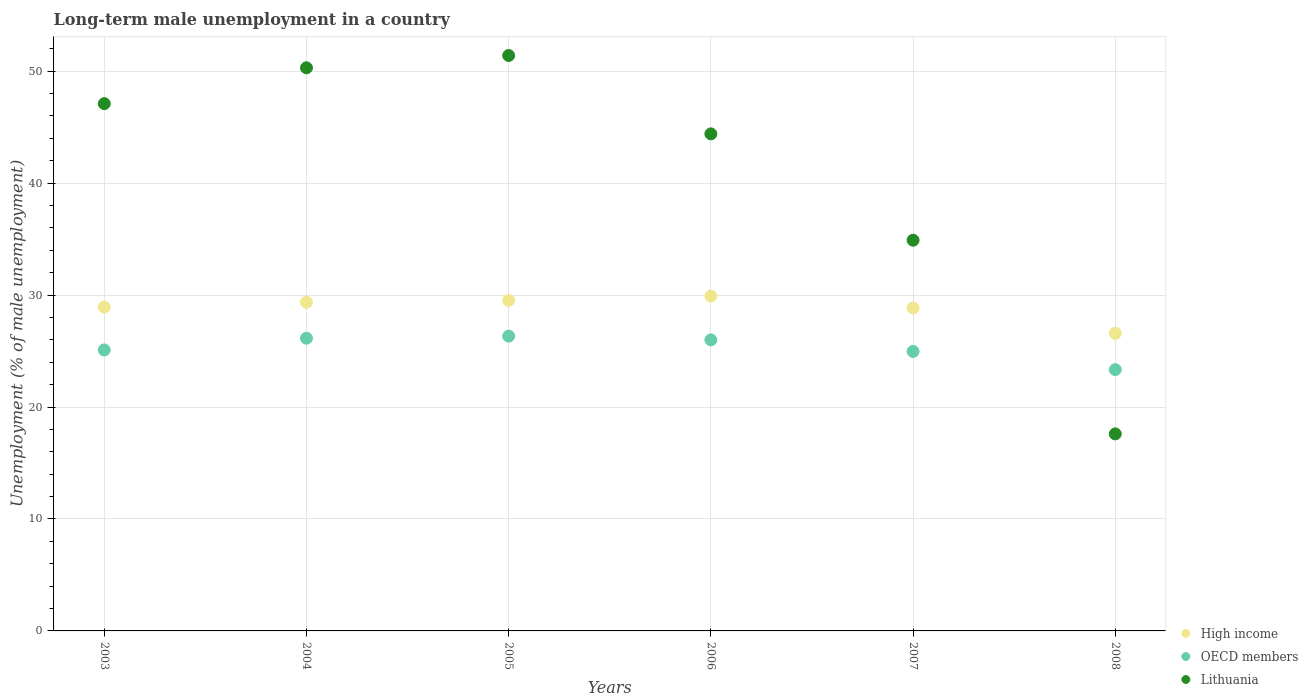How many different coloured dotlines are there?
Provide a short and direct response. 3. What is the percentage of long-term unemployed male population in High income in 2005?
Ensure brevity in your answer.  29.52. Across all years, what is the maximum percentage of long-term unemployed male population in Lithuania?
Offer a very short reply. 51.4. Across all years, what is the minimum percentage of long-term unemployed male population in High income?
Offer a terse response. 26.59. In which year was the percentage of long-term unemployed male population in OECD members maximum?
Your answer should be very brief. 2005. What is the total percentage of long-term unemployed male population in OECD members in the graph?
Your answer should be compact. 151.88. What is the difference between the percentage of long-term unemployed male population in High income in 2003 and that in 2006?
Offer a terse response. -0.98. What is the difference between the percentage of long-term unemployed male population in High income in 2004 and the percentage of long-term unemployed male population in OECD members in 2003?
Give a very brief answer. 4.26. What is the average percentage of long-term unemployed male population in High income per year?
Your response must be concise. 28.86. In the year 2003, what is the difference between the percentage of long-term unemployed male population in OECD members and percentage of long-term unemployed male population in High income?
Offer a terse response. -3.83. What is the ratio of the percentage of long-term unemployed male population in High income in 2003 to that in 2008?
Provide a succinct answer. 1.09. Is the percentage of long-term unemployed male population in OECD members in 2007 less than that in 2008?
Your response must be concise. No. Is the difference between the percentage of long-term unemployed male population in OECD members in 2003 and 2006 greater than the difference between the percentage of long-term unemployed male population in High income in 2003 and 2006?
Offer a terse response. Yes. What is the difference between the highest and the second highest percentage of long-term unemployed male population in High income?
Offer a very short reply. 0.38. What is the difference between the highest and the lowest percentage of long-term unemployed male population in High income?
Offer a terse response. 3.32. In how many years, is the percentage of long-term unemployed male population in Lithuania greater than the average percentage of long-term unemployed male population in Lithuania taken over all years?
Your answer should be compact. 4. Is the percentage of long-term unemployed male population in OECD members strictly greater than the percentage of long-term unemployed male population in High income over the years?
Your response must be concise. No. Is the percentage of long-term unemployed male population in OECD members strictly less than the percentage of long-term unemployed male population in High income over the years?
Your answer should be compact. Yes. How many dotlines are there?
Provide a succinct answer. 3. Are the values on the major ticks of Y-axis written in scientific E-notation?
Make the answer very short. No. What is the title of the graph?
Provide a short and direct response. Long-term male unemployment in a country. What is the label or title of the X-axis?
Provide a short and direct response. Years. What is the label or title of the Y-axis?
Provide a short and direct response. Unemployment (% of male unemployment). What is the Unemployment (% of male unemployment) of High income in 2003?
Offer a terse response. 28.93. What is the Unemployment (% of male unemployment) of OECD members in 2003?
Your answer should be compact. 25.1. What is the Unemployment (% of male unemployment) in Lithuania in 2003?
Your answer should be very brief. 47.1. What is the Unemployment (% of male unemployment) of High income in 2004?
Offer a very short reply. 29.36. What is the Unemployment (% of male unemployment) of OECD members in 2004?
Make the answer very short. 26.15. What is the Unemployment (% of male unemployment) in Lithuania in 2004?
Your answer should be very brief. 50.3. What is the Unemployment (% of male unemployment) in High income in 2005?
Offer a terse response. 29.52. What is the Unemployment (% of male unemployment) of OECD members in 2005?
Give a very brief answer. 26.33. What is the Unemployment (% of male unemployment) of Lithuania in 2005?
Your answer should be compact. 51.4. What is the Unemployment (% of male unemployment) in High income in 2006?
Your answer should be very brief. 29.91. What is the Unemployment (% of male unemployment) in OECD members in 2006?
Your answer should be very brief. 26. What is the Unemployment (% of male unemployment) in Lithuania in 2006?
Your response must be concise. 44.4. What is the Unemployment (% of male unemployment) in High income in 2007?
Your answer should be compact. 28.85. What is the Unemployment (% of male unemployment) of OECD members in 2007?
Keep it short and to the point. 24.96. What is the Unemployment (% of male unemployment) of Lithuania in 2007?
Keep it short and to the point. 34.9. What is the Unemployment (% of male unemployment) of High income in 2008?
Make the answer very short. 26.59. What is the Unemployment (% of male unemployment) of OECD members in 2008?
Your answer should be very brief. 23.34. What is the Unemployment (% of male unemployment) in Lithuania in 2008?
Provide a short and direct response. 17.6. Across all years, what is the maximum Unemployment (% of male unemployment) in High income?
Provide a short and direct response. 29.91. Across all years, what is the maximum Unemployment (% of male unemployment) of OECD members?
Your response must be concise. 26.33. Across all years, what is the maximum Unemployment (% of male unemployment) of Lithuania?
Provide a succinct answer. 51.4. Across all years, what is the minimum Unemployment (% of male unemployment) in High income?
Offer a terse response. 26.59. Across all years, what is the minimum Unemployment (% of male unemployment) of OECD members?
Keep it short and to the point. 23.34. Across all years, what is the minimum Unemployment (% of male unemployment) of Lithuania?
Keep it short and to the point. 17.6. What is the total Unemployment (% of male unemployment) of High income in the graph?
Your response must be concise. 173.15. What is the total Unemployment (% of male unemployment) in OECD members in the graph?
Your answer should be compact. 151.88. What is the total Unemployment (% of male unemployment) of Lithuania in the graph?
Your answer should be very brief. 245.7. What is the difference between the Unemployment (% of male unemployment) of High income in 2003 and that in 2004?
Ensure brevity in your answer.  -0.43. What is the difference between the Unemployment (% of male unemployment) of OECD members in 2003 and that in 2004?
Provide a succinct answer. -1.05. What is the difference between the Unemployment (% of male unemployment) in Lithuania in 2003 and that in 2004?
Ensure brevity in your answer.  -3.2. What is the difference between the Unemployment (% of male unemployment) in High income in 2003 and that in 2005?
Provide a short and direct response. -0.6. What is the difference between the Unemployment (% of male unemployment) of OECD members in 2003 and that in 2005?
Ensure brevity in your answer.  -1.23. What is the difference between the Unemployment (% of male unemployment) in Lithuania in 2003 and that in 2005?
Your answer should be very brief. -4.3. What is the difference between the Unemployment (% of male unemployment) in High income in 2003 and that in 2006?
Provide a short and direct response. -0.98. What is the difference between the Unemployment (% of male unemployment) in OECD members in 2003 and that in 2006?
Give a very brief answer. -0.9. What is the difference between the Unemployment (% of male unemployment) in High income in 2003 and that in 2007?
Ensure brevity in your answer.  0.08. What is the difference between the Unemployment (% of male unemployment) of OECD members in 2003 and that in 2007?
Your answer should be very brief. 0.13. What is the difference between the Unemployment (% of male unemployment) of Lithuania in 2003 and that in 2007?
Offer a very short reply. 12.2. What is the difference between the Unemployment (% of male unemployment) in High income in 2003 and that in 2008?
Provide a short and direct response. 2.34. What is the difference between the Unemployment (% of male unemployment) in OECD members in 2003 and that in 2008?
Offer a very short reply. 1.76. What is the difference between the Unemployment (% of male unemployment) of Lithuania in 2003 and that in 2008?
Your response must be concise. 29.5. What is the difference between the Unemployment (% of male unemployment) of High income in 2004 and that in 2005?
Your answer should be compact. -0.17. What is the difference between the Unemployment (% of male unemployment) in OECD members in 2004 and that in 2005?
Ensure brevity in your answer.  -0.18. What is the difference between the Unemployment (% of male unemployment) in High income in 2004 and that in 2006?
Make the answer very short. -0.55. What is the difference between the Unemployment (% of male unemployment) in OECD members in 2004 and that in 2006?
Keep it short and to the point. 0.15. What is the difference between the Unemployment (% of male unemployment) of Lithuania in 2004 and that in 2006?
Give a very brief answer. 5.9. What is the difference between the Unemployment (% of male unemployment) in High income in 2004 and that in 2007?
Make the answer very short. 0.51. What is the difference between the Unemployment (% of male unemployment) of OECD members in 2004 and that in 2007?
Your response must be concise. 1.18. What is the difference between the Unemployment (% of male unemployment) in High income in 2004 and that in 2008?
Your response must be concise. 2.77. What is the difference between the Unemployment (% of male unemployment) in OECD members in 2004 and that in 2008?
Provide a short and direct response. 2.81. What is the difference between the Unemployment (% of male unemployment) in Lithuania in 2004 and that in 2008?
Give a very brief answer. 32.7. What is the difference between the Unemployment (% of male unemployment) in High income in 2005 and that in 2006?
Ensure brevity in your answer.  -0.38. What is the difference between the Unemployment (% of male unemployment) in OECD members in 2005 and that in 2006?
Ensure brevity in your answer.  0.33. What is the difference between the Unemployment (% of male unemployment) of Lithuania in 2005 and that in 2006?
Provide a short and direct response. 7. What is the difference between the Unemployment (% of male unemployment) of High income in 2005 and that in 2007?
Your response must be concise. 0.67. What is the difference between the Unemployment (% of male unemployment) of OECD members in 2005 and that in 2007?
Your answer should be very brief. 1.37. What is the difference between the Unemployment (% of male unemployment) in Lithuania in 2005 and that in 2007?
Offer a very short reply. 16.5. What is the difference between the Unemployment (% of male unemployment) in High income in 2005 and that in 2008?
Your response must be concise. 2.93. What is the difference between the Unemployment (% of male unemployment) in OECD members in 2005 and that in 2008?
Offer a terse response. 2.99. What is the difference between the Unemployment (% of male unemployment) in Lithuania in 2005 and that in 2008?
Offer a terse response. 33.8. What is the difference between the Unemployment (% of male unemployment) in High income in 2006 and that in 2007?
Make the answer very short. 1.06. What is the difference between the Unemployment (% of male unemployment) in OECD members in 2006 and that in 2007?
Give a very brief answer. 1.04. What is the difference between the Unemployment (% of male unemployment) of High income in 2006 and that in 2008?
Your answer should be compact. 3.32. What is the difference between the Unemployment (% of male unemployment) in OECD members in 2006 and that in 2008?
Offer a very short reply. 2.66. What is the difference between the Unemployment (% of male unemployment) of Lithuania in 2006 and that in 2008?
Offer a terse response. 26.8. What is the difference between the Unemployment (% of male unemployment) in High income in 2007 and that in 2008?
Make the answer very short. 2.26. What is the difference between the Unemployment (% of male unemployment) in OECD members in 2007 and that in 2008?
Offer a very short reply. 1.62. What is the difference between the Unemployment (% of male unemployment) of Lithuania in 2007 and that in 2008?
Ensure brevity in your answer.  17.3. What is the difference between the Unemployment (% of male unemployment) of High income in 2003 and the Unemployment (% of male unemployment) of OECD members in 2004?
Your answer should be compact. 2.78. What is the difference between the Unemployment (% of male unemployment) in High income in 2003 and the Unemployment (% of male unemployment) in Lithuania in 2004?
Your answer should be compact. -21.37. What is the difference between the Unemployment (% of male unemployment) of OECD members in 2003 and the Unemployment (% of male unemployment) of Lithuania in 2004?
Give a very brief answer. -25.2. What is the difference between the Unemployment (% of male unemployment) of High income in 2003 and the Unemployment (% of male unemployment) of OECD members in 2005?
Give a very brief answer. 2.6. What is the difference between the Unemployment (% of male unemployment) of High income in 2003 and the Unemployment (% of male unemployment) of Lithuania in 2005?
Provide a succinct answer. -22.47. What is the difference between the Unemployment (% of male unemployment) of OECD members in 2003 and the Unemployment (% of male unemployment) of Lithuania in 2005?
Offer a very short reply. -26.3. What is the difference between the Unemployment (% of male unemployment) of High income in 2003 and the Unemployment (% of male unemployment) of OECD members in 2006?
Offer a very short reply. 2.93. What is the difference between the Unemployment (% of male unemployment) in High income in 2003 and the Unemployment (% of male unemployment) in Lithuania in 2006?
Your response must be concise. -15.47. What is the difference between the Unemployment (% of male unemployment) of OECD members in 2003 and the Unemployment (% of male unemployment) of Lithuania in 2006?
Provide a succinct answer. -19.3. What is the difference between the Unemployment (% of male unemployment) of High income in 2003 and the Unemployment (% of male unemployment) of OECD members in 2007?
Offer a terse response. 3.96. What is the difference between the Unemployment (% of male unemployment) of High income in 2003 and the Unemployment (% of male unemployment) of Lithuania in 2007?
Give a very brief answer. -5.97. What is the difference between the Unemployment (% of male unemployment) of OECD members in 2003 and the Unemployment (% of male unemployment) of Lithuania in 2007?
Give a very brief answer. -9.8. What is the difference between the Unemployment (% of male unemployment) in High income in 2003 and the Unemployment (% of male unemployment) in OECD members in 2008?
Keep it short and to the point. 5.59. What is the difference between the Unemployment (% of male unemployment) of High income in 2003 and the Unemployment (% of male unemployment) of Lithuania in 2008?
Your answer should be very brief. 11.33. What is the difference between the Unemployment (% of male unemployment) of OECD members in 2003 and the Unemployment (% of male unemployment) of Lithuania in 2008?
Ensure brevity in your answer.  7.5. What is the difference between the Unemployment (% of male unemployment) of High income in 2004 and the Unemployment (% of male unemployment) of OECD members in 2005?
Ensure brevity in your answer.  3.02. What is the difference between the Unemployment (% of male unemployment) in High income in 2004 and the Unemployment (% of male unemployment) in Lithuania in 2005?
Provide a short and direct response. -22.04. What is the difference between the Unemployment (% of male unemployment) in OECD members in 2004 and the Unemployment (% of male unemployment) in Lithuania in 2005?
Your answer should be very brief. -25.25. What is the difference between the Unemployment (% of male unemployment) in High income in 2004 and the Unemployment (% of male unemployment) in OECD members in 2006?
Give a very brief answer. 3.36. What is the difference between the Unemployment (% of male unemployment) in High income in 2004 and the Unemployment (% of male unemployment) in Lithuania in 2006?
Keep it short and to the point. -15.04. What is the difference between the Unemployment (% of male unemployment) in OECD members in 2004 and the Unemployment (% of male unemployment) in Lithuania in 2006?
Ensure brevity in your answer.  -18.25. What is the difference between the Unemployment (% of male unemployment) of High income in 2004 and the Unemployment (% of male unemployment) of OECD members in 2007?
Your response must be concise. 4.39. What is the difference between the Unemployment (% of male unemployment) in High income in 2004 and the Unemployment (% of male unemployment) in Lithuania in 2007?
Ensure brevity in your answer.  -5.54. What is the difference between the Unemployment (% of male unemployment) of OECD members in 2004 and the Unemployment (% of male unemployment) of Lithuania in 2007?
Your response must be concise. -8.75. What is the difference between the Unemployment (% of male unemployment) in High income in 2004 and the Unemployment (% of male unemployment) in OECD members in 2008?
Keep it short and to the point. 6.01. What is the difference between the Unemployment (% of male unemployment) of High income in 2004 and the Unemployment (% of male unemployment) of Lithuania in 2008?
Provide a short and direct response. 11.76. What is the difference between the Unemployment (% of male unemployment) in OECD members in 2004 and the Unemployment (% of male unemployment) in Lithuania in 2008?
Ensure brevity in your answer.  8.55. What is the difference between the Unemployment (% of male unemployment) in High income in 2005 and the Unemployment (% of male unemployment) in OECD members in 2006?
Make the answer very short. 3.52. What is the difference between the Unemployment (% of male unemployment) in High income in 2005 and the Unemployment (% of male unemployment) in Lithuania in 2006?
Offer a very short reply. -14.88. What is the difference between the Unemployment (% of male unemployment) of OECD members in 2005 and the Unemployment (% of male unemployment) of Lithuania in 2006?
Your answer should be compact. -18.07. What is the difference between the Unemployment (% of male unemployment) in High income in 2005 and the Unemployment (% of male unemployment) in OECD members in 2007?
Provide a short and direct response. 4.56. What is the difference between the Unemployment (% of male unemployment) in High income in 2005 and the Unemployment (% of male unemployment) in Lithuania in 2007?
Offer a terse response. -5.38. What is the difference between the Unemployment (% of male unemployment) in OECD members in 2005 and the Unemployment (% of male unemployment) in Lithuania in 2007?
Provide a short and direct response. -8.57. What is the difference between the Unemployment (% of male unemployment) in High income in 2005 and the Unemployment (% of male unemployment) in OECD members in 2008?
Make the answer very short. 6.18. What is the difference between the Unemployment (% of male unemployment) in High income in 2005 and the Unemployment (% of male unemployment) in Lithuania in 2008?
Give a very brief answer. 11.92. What is the difference between the Unemployment (% of male unemployment) of OECD members in 2005 and the Unemployment (% of male unemployment) of Lithuania in 2008?
Your answer should be compact. 8.73. What is the difference between the Unemployment (% of male unemployment) in High income in 2006 and the Unemployment (% of male unemployment) in OECD members in 2007?
Keep it short and to the point. 4.94. What is the difference between the Unemployment (% of male unemployment) of High income in 2006 and the Unemployment (% of male unemployment) of Lithuania in 2007?
Provide a short and direct response. -4.99. What is the difference between the Unemployment (% of male unemployment) of OECD members in 2006 and the Unemployment (% of male unemployment) of Lithuania in 2007?
Provide a short and direct response. -8.9. What is the difference between the Unemployment (% of male unemployment) of High income in 2006 and the Unemployment (% of male unemployment) of OECD members in 2008?
Offer a terse response. 6.56. What is the difference between the Unemployment (% of male unemployment) in High income in 2006 and the Unemployment (% of male unemployment) in Lithuania in 2008?
Offer a terse response. 12.31. What is the difference between the Unemployment (% of male unemployment) of OECD members in 2006 and the Unemployment (% of male unemployment) of Lithuania in 2008?
Your answer should be compact. 8.4. What is the difference between the Unemployment (% of male unemployment) of High income in 2007 and the Unemployment (% of male unemployment) of OECD members in 2008?
Give a very brief answer. 5.51. What is the difference between the Unemployment (% of male unemployment) in High income in 2007 and the Unemployment (% of male unemployment) in Lithuania in 2008?
Keep it short and to the point. 11.25. What is the difference between the Unemployment (% of male unemployment) of OECD members in 2007 and the Unemployment (% of male unemployment) of Lithuania in 2008?
Make the answer very short. 7.36. What is the average Unemployment (% of male unemployment) in High income per year?
Your answer should be very brief. 28.86. What is the average Unemployment (% of male unemployment) in OECD members per year?
Your answer should be compact. 25.31. What is the average Unemployment (% of male unemployment) in Lithuania per year?
Your response must be concise. 40.95. In the year 2003, what is the difference between the Unemployment (% of male unemployment) of High income and Unemployment (% of male unemployment) of OECD members?
Your response must be concise. 3.83. In the year 2003, what is the difference between the Unemployment (% of male unemployment) of High income and Unemployment (% of male unemployment) of Lithuania?
Offer a terse response. -18.17. In the year 2003, what is the difference between the Unemployment (% of male unemployment) of OECD members and Unemployment (% of male unemployment) of Lithuania?
Make the answer very short. -22. In the year 2004, what is the difference between the Unemployment (% of male unemployment) in High income and Unemployment (% of male unemployment) in OECD members?
Ensure brevity in your answer.  3.21. In the year 2004, what is the difference between the Unemployment (% of male unemployment) of High income and Unemployment (% of male unemployment) of Lithuania?
Your answer should be very brief. -20.94. In the year 2004, what is the difference between the Unemployment (% of male unemployment) of OECD members and Unemployment (% of male unemployment) of Lithuania?
Offer a terse response. -24.15. In the year 2005, what is the difference between the Unemployment (% of male unemployment) in High income and Unemployment (% of male unemployment) in OECD members?
Give a very brief answer. 3.19. In the year 2005, what is the difference between the Unemployment (% of male unemployment) of High income and Unemployment (% of male unemployment) of Lithuania?
Make the answer very short. -21.88. In the year 2005, what is the difference between the Unemployment (% of male unemployment) in OECD members and Unemployment (% of male unemployment) in Lithuania?
Offer a very short reply. -25.07. In the year 2006, what is the difference between the Unemployment (% of male unemployment) in High income and Unemployment (% of male unemployment) in OECD members?
Your answer should be very brief. 3.91. In the year 2006, what is the difference between the Unemployment (% of male unemployment) in High income and Unemployment (% of male unemployment) in Lithuania?
Provide a succinct answer. -14.49. In the year 2006, what is the difference between the Unemployment (% of male unemployment) in OECD members and Unemployment (% of male unemployment) in Lithuania?
Your answer should be compact. -18.4. In the year 2007, what is the difference between the Unemployment (% of male unemployment) in High income and Unemployment (% of male unemployment) in OECD members?
Keep it short and to the point. 3.88. In the year 2007, what is the difference between the Unemployment (% of male unemployment) of High income and Unemployment (% of male unemployment) of Lithuania?
Give a very brief answer. -6.05. In the year 2007, what is the difference between the Unemployment (% of male unemployment) of OECD members and Unemployment (% of male unemployment) of Lithuania?
Your answer should be compact. -9.94. In the year 2008, what is the difference between the Unemployment (% of male unemployment) in High income and Unemployment (% of male unemployment) in OECD members?
Give a very brief answer. 3.25. In the year 2008, what is the difference between the Unemployment (% of male unemployment) in High income and Unemployment (% of male unemployment) in Lithuania?
Keep it short and to the point. 8.99. In the year 2008, what is the difference between the Unemployment (% of male unemployment) in OECD members and Unemployment (% of male unemployment) in Lithuania?
Your response must be concise. 5.74. What is the ratio of the Unemployment (% of male unemployment) in High income in 2003 to that in 2004?
Give a very brief answer. 0.99. What is the ratio of the Unemployment (% of male unemployment) of OECD members in 2003 to that in 2004?
Make the answer very short. 0.96. What is the ratio of the Unemployment (% of male unemployment) of Lithuania in 2003 to that in 2004?
Your answer should be very brief. 0.94. What is the ratio of the Unemployment (% of male unemployment) in High income in 2003 to that in 2005?
Provide a short and direct response. 0.98. What is the ratio of the Unemployment (% of male unemployment) in OECD members in 2003 to that in 2005?
Your response must be concise. 0.95. What is the ratio of the Unemployment (% of male unemployment) of Lithuania in 2003 to that in 2005?
Provide a short and direct response. 0.92. What is the ratio of the Unemployment (% of male unemployment) in High income in 2003 to that in 2006?
Make the answer very short. 0.97. What is the ratio of the Unemployment (% of male unemployment) of OECD members in 2003 to that in 2006?
Your answer should be compact. 0.97. What is the ratio of the Unemployment (% of male unemployment) of Lithuania in 2003 to that in 2006?
Offer a very short reply. 1.06. What is the ratio of the Unemployment (% of male unemployment) of OECD members in 2003 to that in 2007?
Ensure brevity in your answer.  1.01. What is the ratio of the Unemployment (% of male unemployment) in Lithuania in 2003 to that in 2007?
Your response must be concise. 1.35. What is the ratio of the Unemployment (% of male unemployment) in High income in 2003 to that in 2008?
Your response must be concise. 1.09. What is the ratio of the Unemployment (% of male unemployment) of OECD members in 2003 to that in 2008?
Provide a short and direct response. 1.08. What is the ratio of the Unemployment (% of male unemployment) of Lithuania in 2003 to that in 2008?
Your answer should be compact. 2.68. What is the ratio of the Unemployment (% of male unemployment) in OECD members in 2004 to that in 2005?
Give a very brief answer. 0.99. What is the ratio of the Unemployment (% of male unemployment) of Lithuania in 2004 to that in 2005?
Make the answer very short. 0.98. What is the ratio of the Unemployment (% of male unemployment) of High income in 2004 to that in 2006?
Provide a succinct answer. 0.98. What is the ratio of the Unemployment (% of male unemployment) in Lithuania in 2004 to that in 2006?
Your answer should be compact. 1.13. What is the ratio of the Unemployment (% of male unemployment) in High income in 2004 to that in 2007?
Provide a succinct answer. 1.02. What is the ratio of the Unemployment (% of male unemployment) of OECD members in 2004 to that in 2007?
Offer a very short reply. 1.05. What is the ratio of the Unemployment (% of male unemployment) of Lithuania in 2004 to that in 2007?
Offer a terse response. 1.44. What is the ratio of the Unemployment (% of male unemployment) of High income in 2004 to that in 2008?
Your response must be concise. 1.1. What is the ratio of the Unemployment (% of male unemployment) in OECD members in 2004 to that in 2008?
Provide a succinct answer. 1.12. What is the ratio of the Unemployment (% of male unemployment) in Lithuania in 2004 to that in 2008?
Your answer should be compact. 2.86. What is the ratio of the Unemployment (% of male unemployment) in High income in 2005 to that in 2006?
Make the answer very short. 0.99. What is the ratio of the Unemployment (% of male unemployment) in OECD members in 2005 to that in 2006?
Keep it short and to the point. 1.01. What is the ratio of the Unemployment (% of male unemployment) in Lithuania in 2005 to that in 2006?
Your answer should be very brief. 1.16. What is the ratio of the Unemployment (% of male unemployment) in High income in 2005 to that in 2007?
Make the answer very short. 1.02. What is the ratio of the Unemployment (% of male unemployment) in OECD members in 2005 to that in 2007?
Your response must be concise. 1.05. What is the ratio of the Unemployment (% of male unemployment) in Lithuania in 2005 to that in 2007?
Offer a very short reply. 1.47. What is the ratio of the Unemployment (% of male unemployment) of High income in 2005 to that in 2008?
Give a very brief answer. 1.11. What is the ratio of the Unemployment (% of male unemployment) of OECD members in 2005 to that in 2008?
Make the answer very short. 1.13. What is the ratio of the Unemployment (% of male unemployment) in Lithuania in 2005 to that in 2008?
Keep it short and to the point. 2.92. What is the ratio of the Unemployment (% of male unemployment) in High income in 2006 to that in 2007?
Offer a very short reply. 1.04. What is the ratio of the Unemployment (% of male unemployment) in OECD members in 2006 to that in 2007?
Keep it short and to the point. 1.04. What is the ratio of the Unemployment (% of male unemployment) in Lithuania in 2006 to that in 2007?
Keep it short and to the point. 1.27. What is the ratio of the Unemployment (% of male unemployment) in High income in 2006 to that in 2008?
Keep it short and to the point. 1.12. What is the ratio of the Unemployment (% of male unemployment) of OECD members in 2006 to that in 2008?
Provide a succinct answer. 1.11. What is the ratio of the Unemployment (% of male unemployment) of Lithuania in 2006 to that in 2008?
Give a very brief answer. 2.52. What is the ratio of the Unemployment (% of male unemployment) of High income in 2007 to that in 2008?
Provide a succinct answer. 1.08. What is the ratio of the Unemployment (% of male unemployment) in OECD members in 2007 to that in 2008?
Your answer should be compact. 1.07. What is the ratio of the Unemployment (% of male unemployment) in Lithuania in 2007 to that in 2008?
Keep it short and to the point. 1.98. What is the difference between the highest and the second highest Unemployment (% of male unemployment) of High income?
Provide a succinct answer. 0.38. What is the difference between the highest and the second highest Unemployment (% of male unemployment) in OECD members?
Keep it short and to the point. 0.18. What is the difference between the highest and the lowest Unemployment (% of male unemployment) of High income?
Offer a very short reply. 3.32. What is the difference between the highest and the lowest Unemployment (% of male unemployment) in OECD members?
Keep it short and to the point. 2.99. What is the difference between the highest and the lowest Unemployment (% of male unemployment) in Lithuania?
Provide a succinct answer. 33.8. 